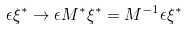Convert formula to latex. <formula><loc_0><loc_0><loc_500><loc_500>\epsilon \xi ^ { * } \to \epsilon M ^ { * } \xi ^ { * } = M ^ { - 1 } \epsilon \xi ^ { * }</formula> 